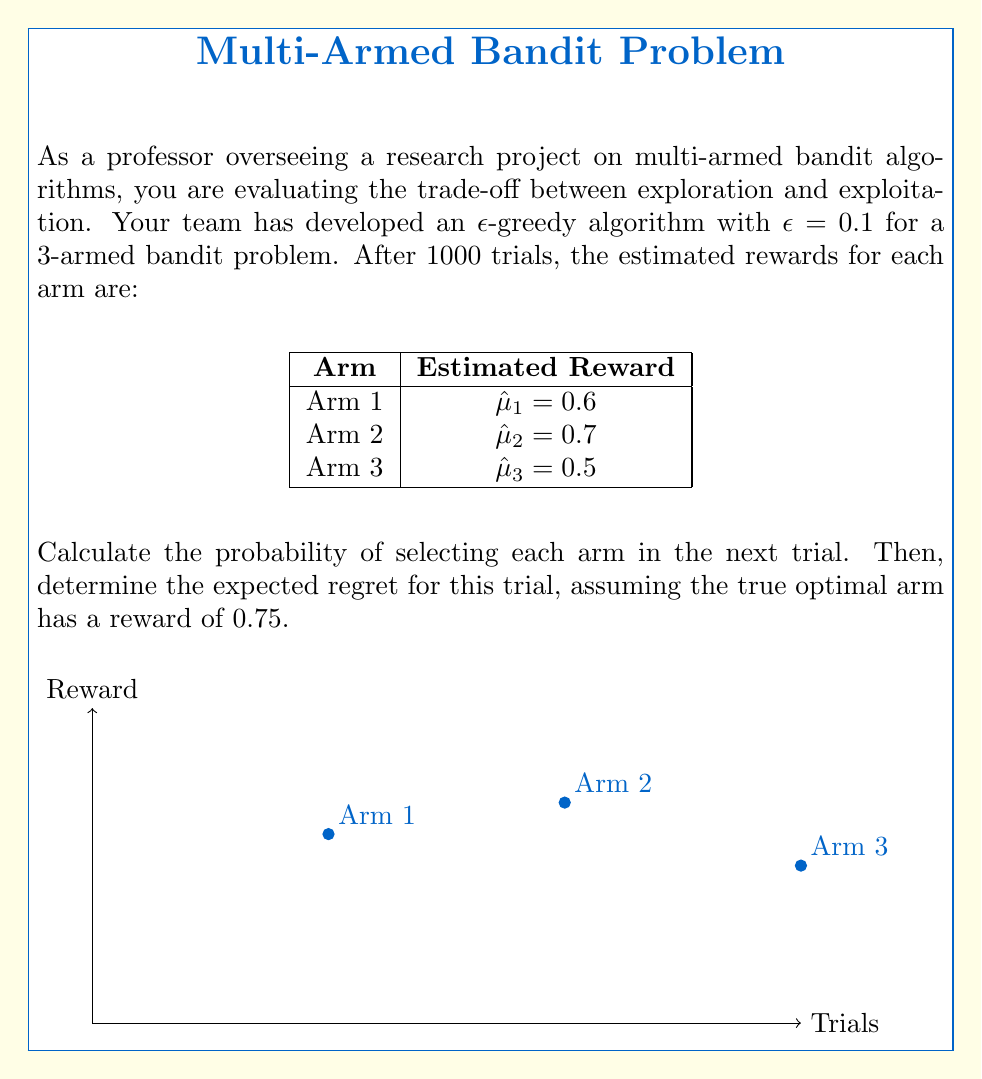Can you solve this math problem? Let's approach this step-by-step:

1) In an $\epsilon$-greedy algorithm, we exploit (choose the best arm) with probability $1-\epsilon$ and explore (choose a random arm) with probability $\epsilon$.

2) The best arm based on current estimates is Arm 2 with $\hat{\mu}_2 = 0.7$.

3) Probability of selecting each arm:

   a) Arm 2 (best arm):
      $P(\text{Arm 2}) = (1-\epsilon) + \frac{\epsilon}{3} = 0.9 + \frac{0.1}{3} = 0.9333$

   b) Arm 1 and Arm 3:
      $P(\text{Arm 1}) = P(\text{Arm 3}) = \frac{\epsilon}{3} = \frac{0.1}{3} = 0.0333$

4) Expected reward for the next trial:
   $E[R] = 0.9333 \cdot 0.7 + 0.0333 \cdot 0.6 + 0.0333 \cdot 0.5 = 0.6933$

5) The regret is the difference between the optimal reward and the expected reward:
   $\text{Regret} = 0.75 - 0.6933 = 0.0567$

Therefore, the probability of selecting each arm in the next trial is 0.9333 for Arm 2, and 0.0333 each for Arms 1 and 3. The expected regret for this trial is 0.0567.
Answer: Probabilities: Arm 1: 0.0333, Arm 2: 0.9333, Arm 3: 0.0333. Expected regret: 0.0567. 